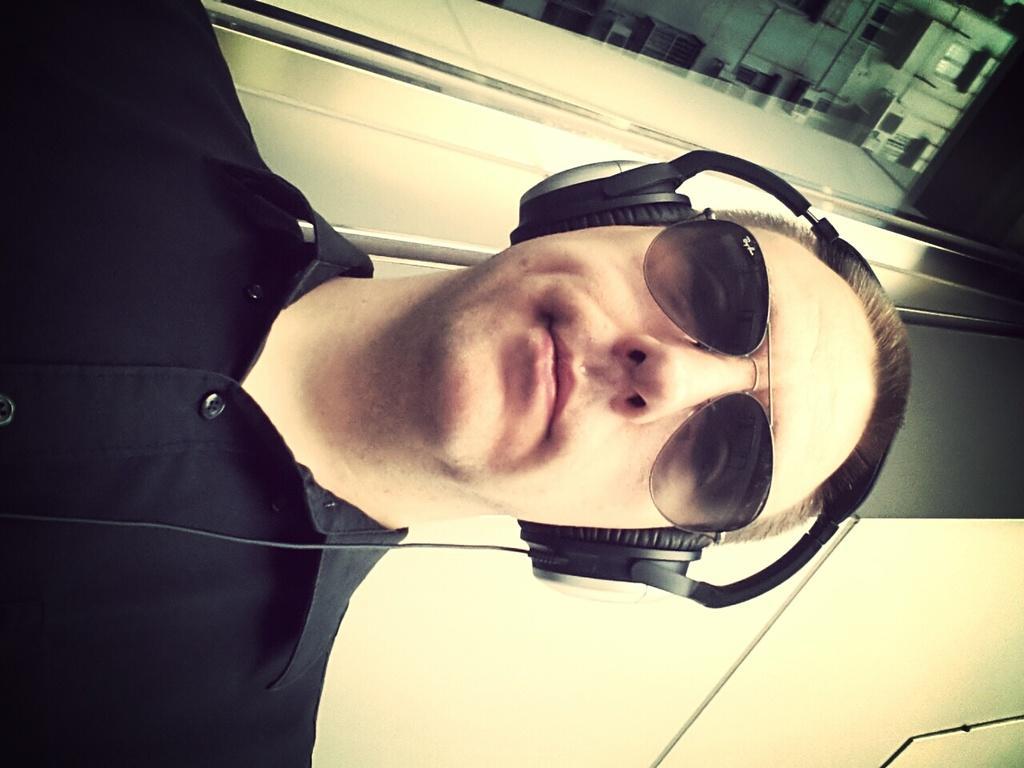How would you summarize this image in a sentence or two? In this image, we can see a person with headphones is wearing spectacles. We can also see the wall and a building. 